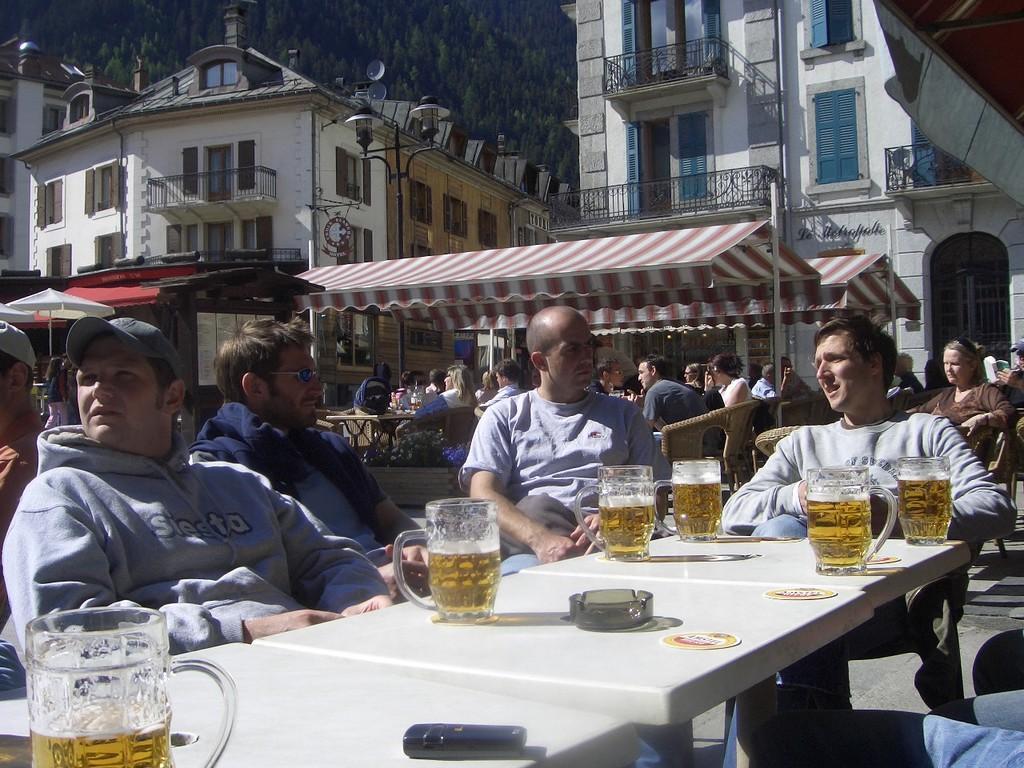Describe this image in one or two sentences. In this image I see number of people who are sitting on chairs and there is a table in front of them and there are glasses on it. In the background I see the buildings and trees. 